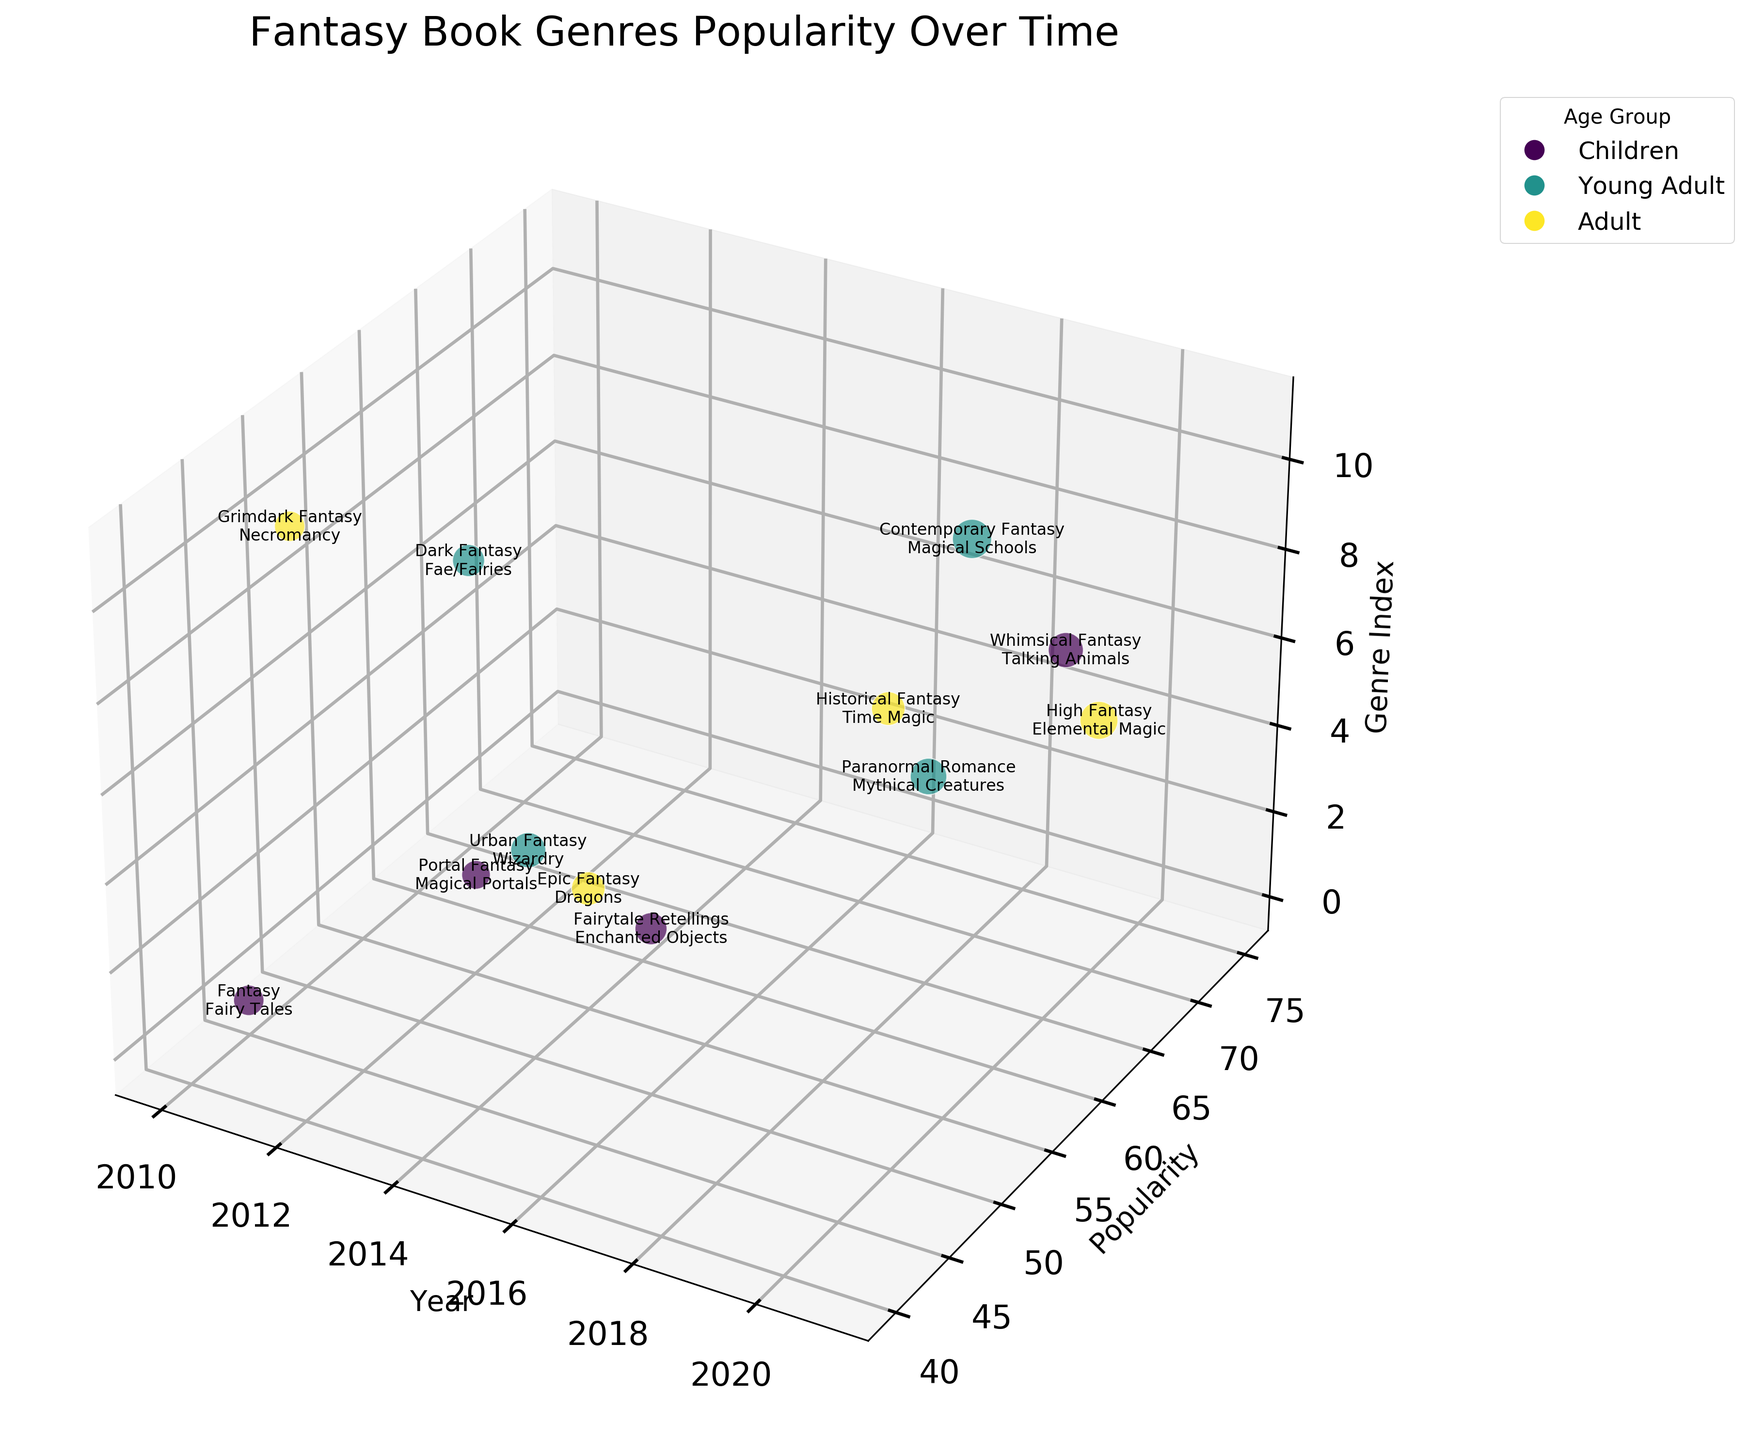what's the title of the figure? The title is displayed at the top of the figure, usually in a larger font size than other text.
Answer: Fantasy Book Genres Popularity Over Time what years are shown on the x-axis? Check the x-axis labels to see which years are included in the plot.
Answer: 2010, 2011, 2012, 2013, 2014, 2015, 2016, 2017, 2018, 2019, 2020, 2021 which age group has the highest popularity in 2020? Look at the data point on the x-axis for the year 2020 and see which age group the point's color represents.
Answer: Adult how do the popularity scores for children vs. young adult compare over the years? Compare the popularity scores for data points colored for "Children" and "Young Adult" across different years, noting if one is generally higher than the other.
Answer: Young Adult generally has higher popularity scores what is the genre of the most popular book in 2017? Find the data point with the highest popularity in 2017 and read the genre label text at that point.
Answer: Contemporary Fantasy which year saw the least popular book genre and what was it? Find the data point with the lowest popularity score on the y-axis and check the corresponding year and genre.
Answer: 2015, Portal Fantasy what is the average popularity score of Adult-targeted books mentioned in the chart? Identify all data points for "Adult" age group, sum their popularity scores, and divide by the number of such data points.
Answer: (55+70+55+45) / 4 = 56.25 which magical theme appears most frequently in the chart? Count the occurrences of each magical theme label at the data points, and identify which one appears most.
Answer: Each theme appears only once how many different fantasy genres are depicted in the chart? Identify each unique genre label from the data points and count them.
Answer: 12 in which year did children’s books have their highest popularity and what magical theme was featured? Look at the color-coded data points for "Children" age group and find the one with the highest popularity, noting the year and corresponding theme.
Answer: 2021, Talking Animals 